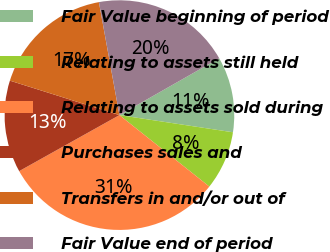Convert chart to OTSL. <chart><loc_0><loc_0><loc_500><loc_500><pie_chart><fcel>Fair Value beginning of period<fcel>Relating to assets still held<fcel>Relating to assets sold during<fcel>Purchases sales and<fcel>Transfers in and/or out of<fcel>Fair Value end of period<nl><fcel>10.63%<fcel>8.3%<fcel>31.2%<fcel>12.96%<fcel>17.29%<fcel>19.62%<nl></chart> 